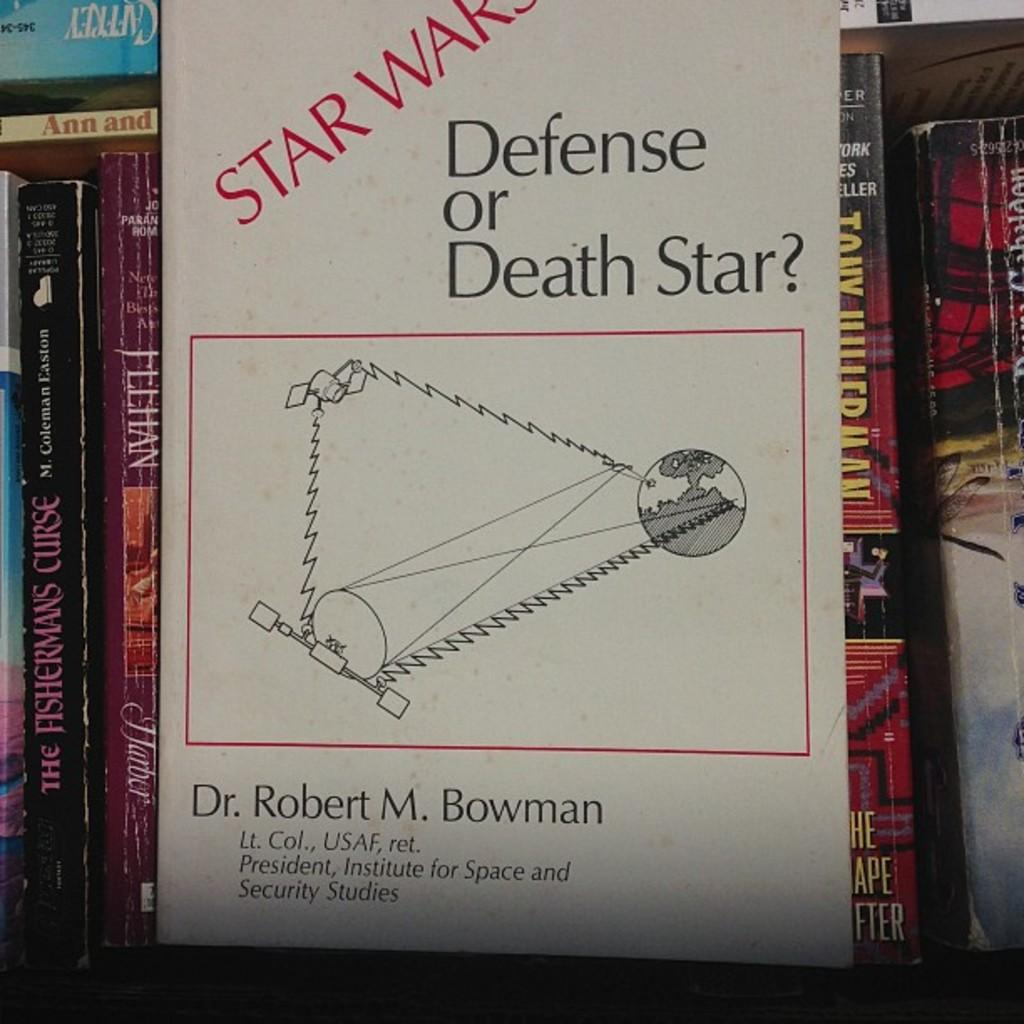<image>
Relay a brief, clear account of the picture shown. a book shelf with Star Wars Defense or Death Star on the front 